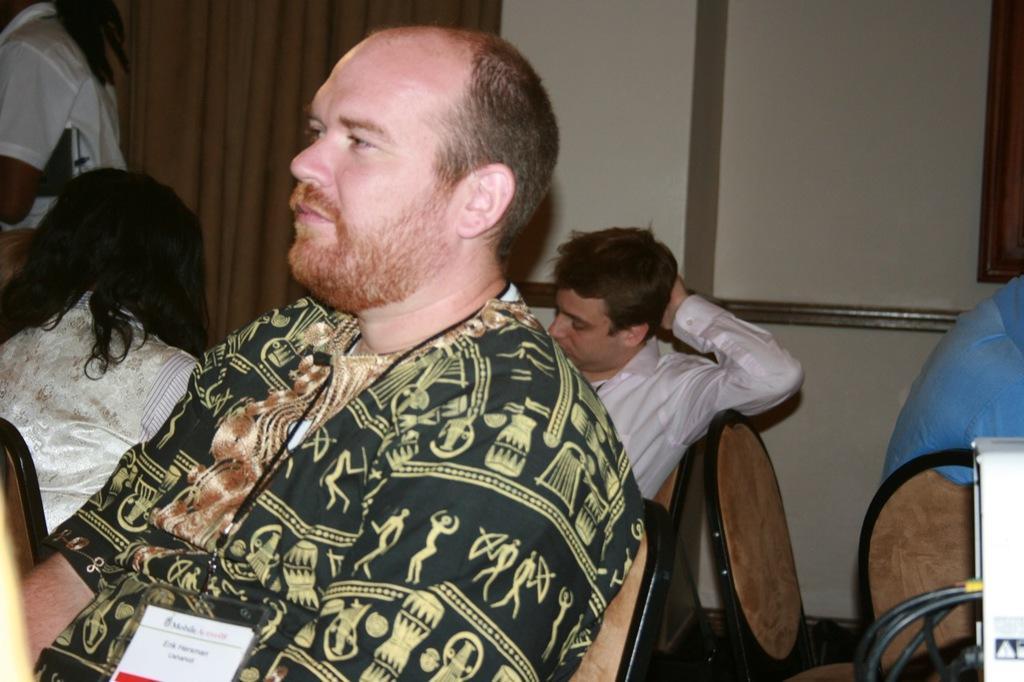How would you summarize this image in a sentence or two? In the foreground of the picture there is a person sitting, behind him there are chairs and people. On the left there are two women. In the background there are curtain and a wall. 